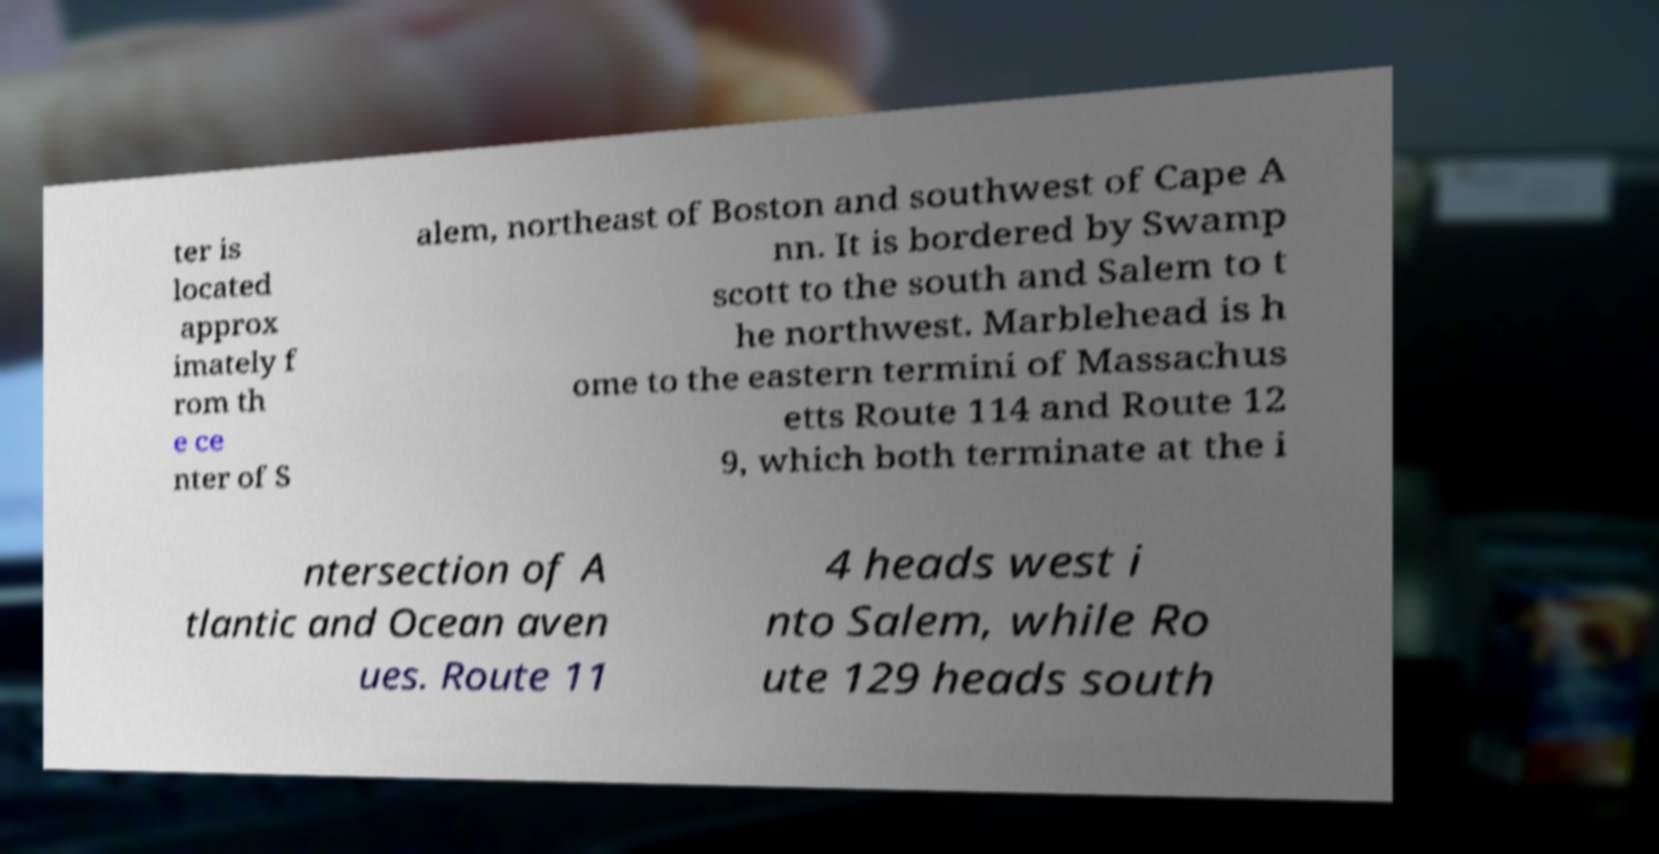Can you accurately transcribe the text from the provided image for me? ter is located approx imately f rom th e ce nter of S alem, northeast of Boston and southwest of Cape A nn. It is bordered by Swamp scott to the south and Salem to t he northwest. Marblehead is h ome to the eastern termini of Massachus etts Route 114 and Route 12 9, which both terminate at the i ntersection of A tlantic and Ocean aven ues. Route 11 4 heads west i nto Salem, while Ro ute 129 heads south 